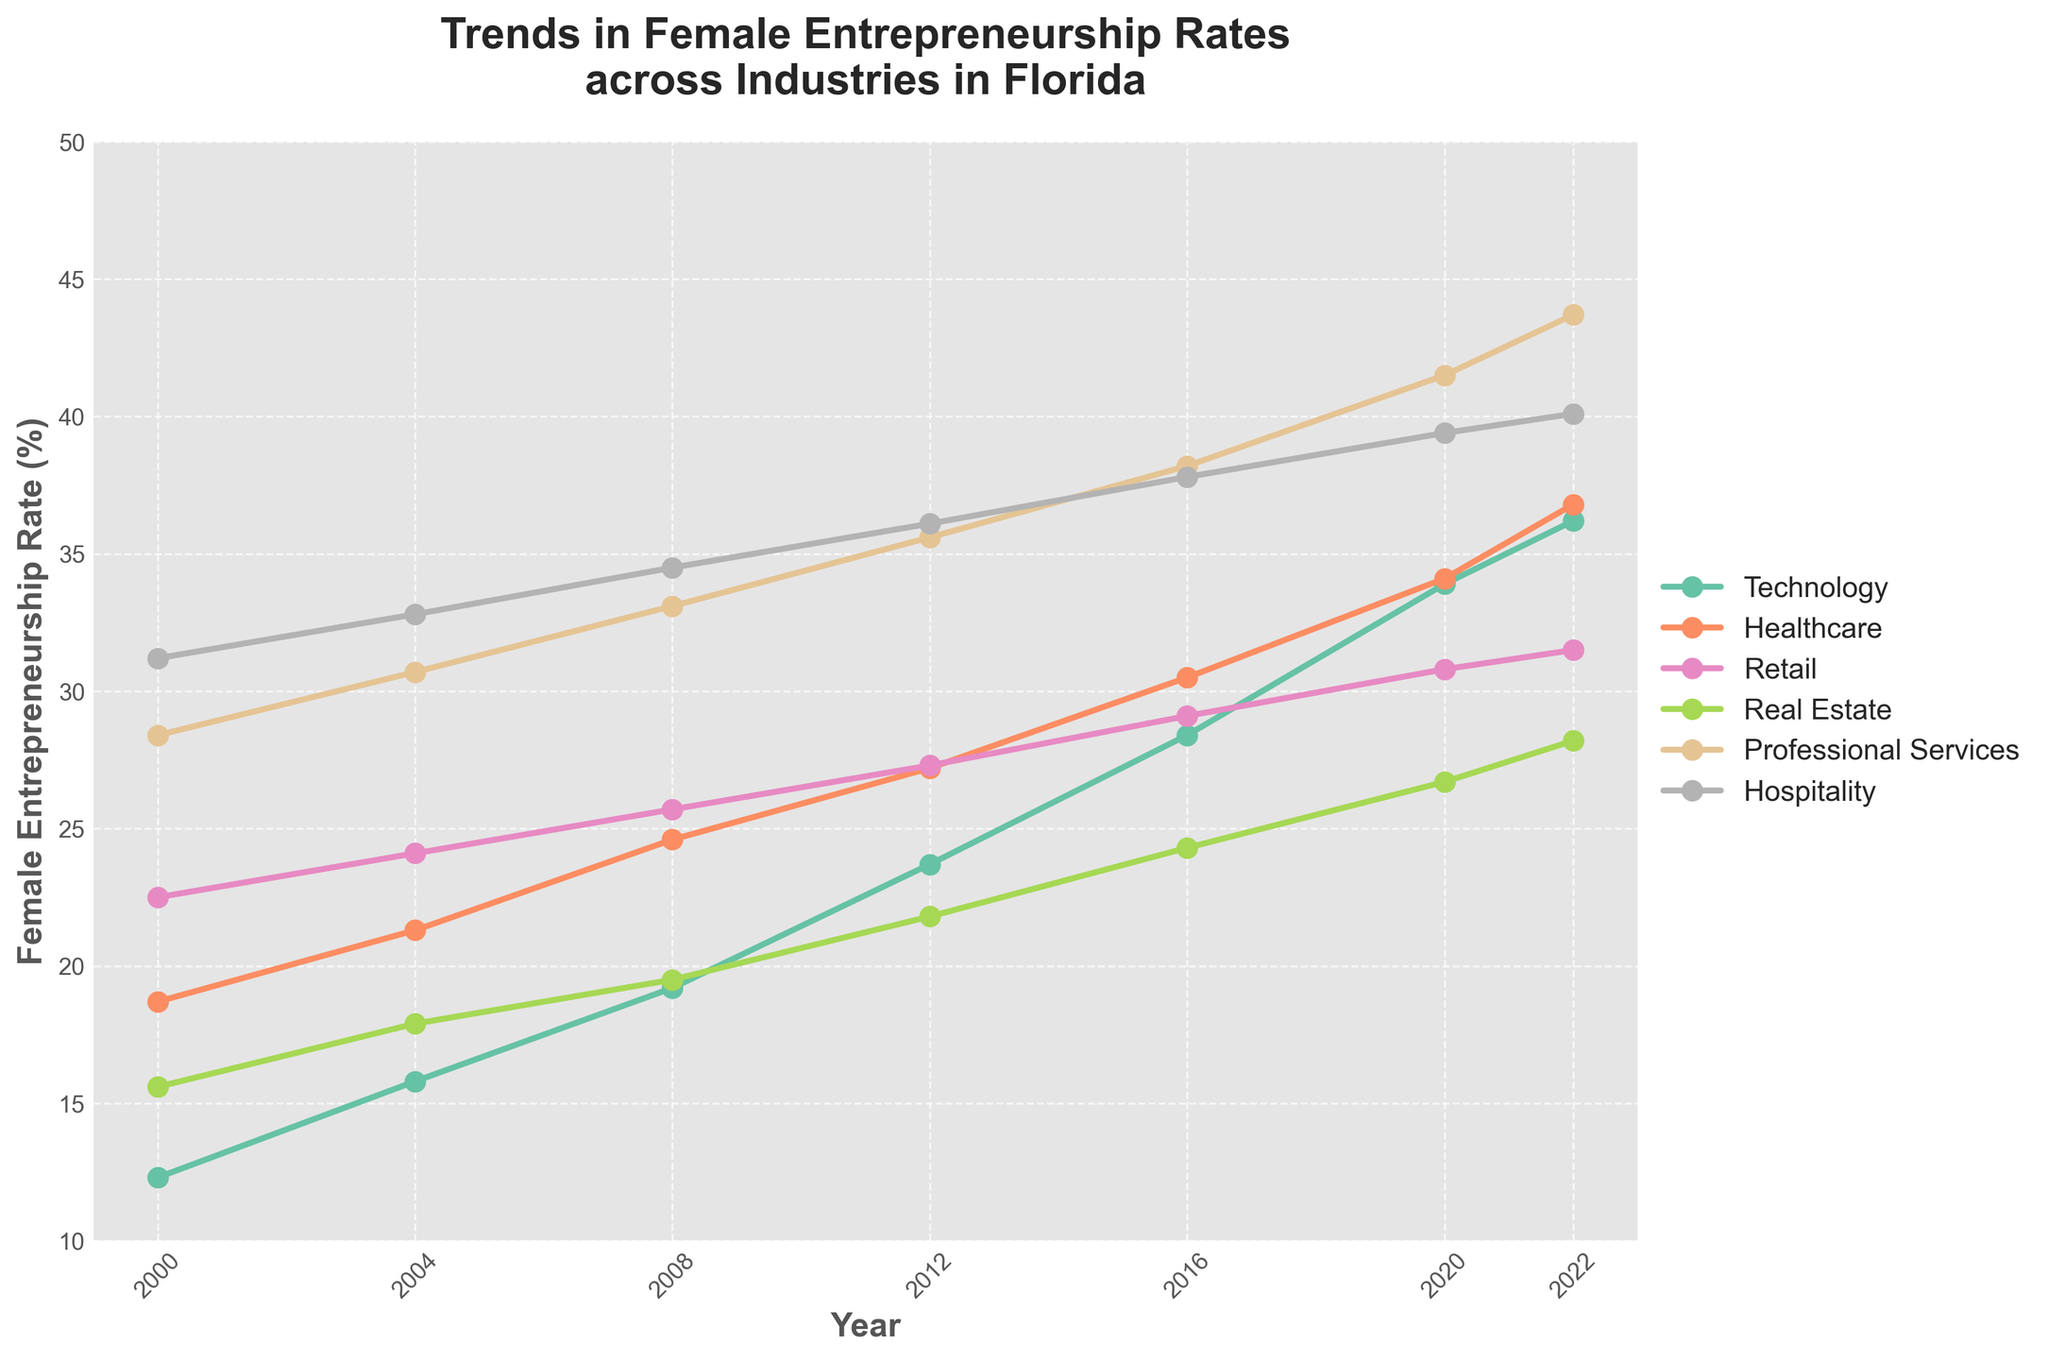What industry has the highest female entrepreneurship rate in 2022? Looking at the data for 2022, the Professional Services industry has the highest value among all the industries depicted.
Answer: Professional Services How much did the female entrepreneurship rate in the Technology industry increase from 2000 to 2022? Subtract the rate in 2000 (12.3%) from the rate in 2022 (36.2%). \( 36.2 - 12.3 = 23.9 \)
Answer: 23.9% Which industry experienced the smallest increase in female entrepreneurship rate between 2000 and 2022? Calculate the difference for each industry between 2000 and 2022 and find the smallest one: Technology \(23.9\), Healthcare \(18.1\), Retail \(9\), Real Estate \(12.6\), Professional Services \(15.3\), Hospitality \(8.9\). Retail has the smallest increase.
Answer: Retail What is the average female entrepreneurship rate in the Hospitality industry over the entire period? Sum the rates for Hospitality from 2000 to 2022 and divide by the number of years. \( (31.2 + 32.8 + 34.5 + 36.1 + 37.8 + 39.4 + 40.1) / 7 = 36.28 \).
Answer: 36.28 Between which consecutive years did the Real Estate industry see the biggest increase in female entrepreneurship rate? Compare the increase between consecutive years: 2000 to 2004 \(2.3\), 2004 to 2008 \(1.6\), 2008 to 2012 \(2.3\), 2012 to 2016 \(2.5\), 2016 to 2020 \(2.4\), 2020 to 2022 \(1.5\). The biggest increase was 2.5 between 2012 and 2016.
Answer: 2012-2016 Did the female entrepreneurship rate in Healthcare ever surpass the rate in Retail? Compare the rates for each year: 2000 (Retail > Healthcare), 2004 (Retail > Healthcare), 2008 (Retail > Healthcare), 2012 (Retail > Healthcare), 2016 (Retail > Healthcare), 2020 (Retail > Healthcare), 2022 (Retail > Healthcare). In all years, Retail was higher.
Answer: No In which year did the Professional Services industry see the highest rate increase compared to the previous period? Calculate the differences for Professional Services: 2000 to 2004 \(2.3\), 2004 to 2008 \(2.4\), 2008 to 2012 \(2.5\), 2012 to 2016 \(2.6\), 2016 to 2020 \(3.3\), 2020 to 2022 \(2.2\). The highest increase was 3.3 from 2016 to 2020.
Answer: 2016-2020 What is the difference in female entrepreneurship rates between Technology and Hospitality in 2022? Subtract the rate in Technology (36.2%) from the rate in Hospitality (40.1%). \( 40.1 - 36.2 = 3.9 \).
Answer: 3.9% By how many percentage points did the female entrepreneurship rate in Professional Services surpass the Healthcare industry in 2020? Subtract the rate in Healthcare (34.1%) from the rate in Professional Services (41.5%). \( 41.5 - 34.1 = 7.4 \).
Answer: 7.4% Which industry had the smallest fluctuation in female entrepreneurship rates from 2000 to 2022? Calculate the range (highest - lowest) for each industry: Technology (23.9), Healthcare (18.1), Retail (9), Real Estate (12.6), Professional Services (15.3), Hospitality (8.9). Hospitality had the smallest fluctuation of 8.9.
Answer: Hospitality 